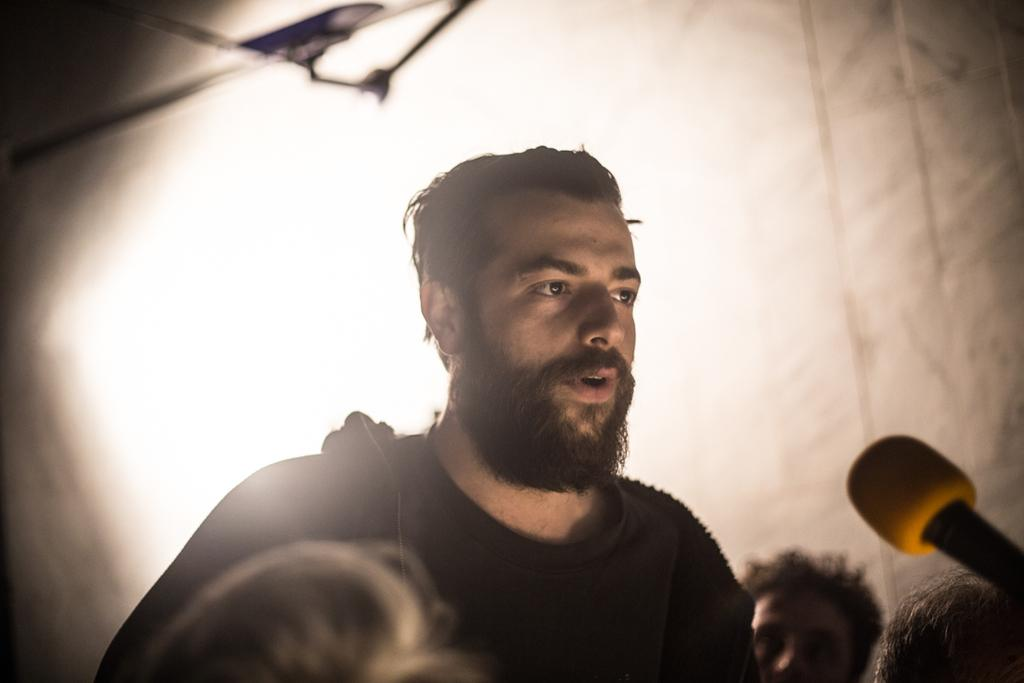Who or what is the main subject in the image? There is a person in the image. What object is located on the right side of the image? There is a microphone on the right side of the image. Are there any other people in the image besides the main subject? Yes, there are other people in the image. What can be seen in the background of the image? There is light visible in the background of the image. What type of rat can be seen eating popcorn in the image? There is no rat or popcorn present in the image; it features a person and a microphone. What design elements are present in the image? The image does not focus on design elements, but rather on the person and the microphone. 